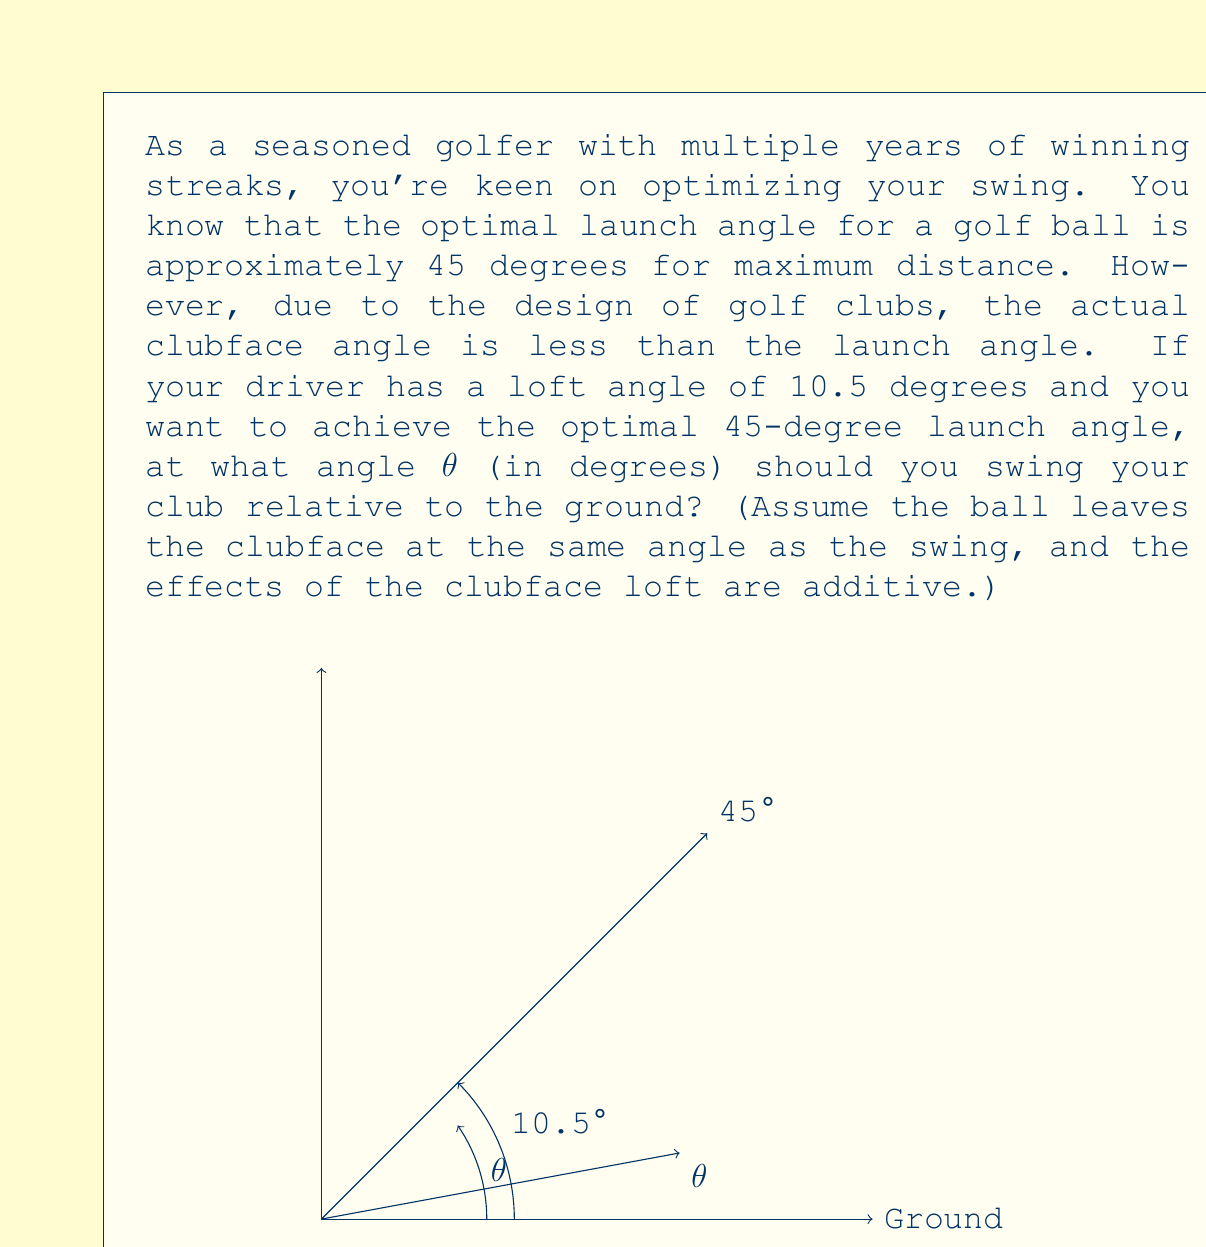Could you help me with this problem? Let's approach this step-by-step:

1) We know that the optimal launch angle is 45 degrees, and this is the sum of two angles:
   - The angle of the swing relative to the ground (θ)
   - The loft angle of the club (10.5 degrees)

2) We can express this as an equation:
   $$ \theta + 10.5° = 45° $$

3) To solve for θ, we simply subtract 10.5° from both sides:
   $$ \theta = 45° - 10.5° $$

4) Perform the subtraction:
   $$ \theta = 34.5° $$

5) Therefore, to achieve the optimal launch angle of 45 degrees with a driver that has a loft angle of 10.5 degrees, you should swing at an angle of 34.5 degrees relative to the ground.

This problem demonstrates the practical application of angle addition in trigonometry, which is a fundamental concept in precalculus and is directly relevant to optimizing a golf swing.
Answer: $\theta = 34.5°$ 